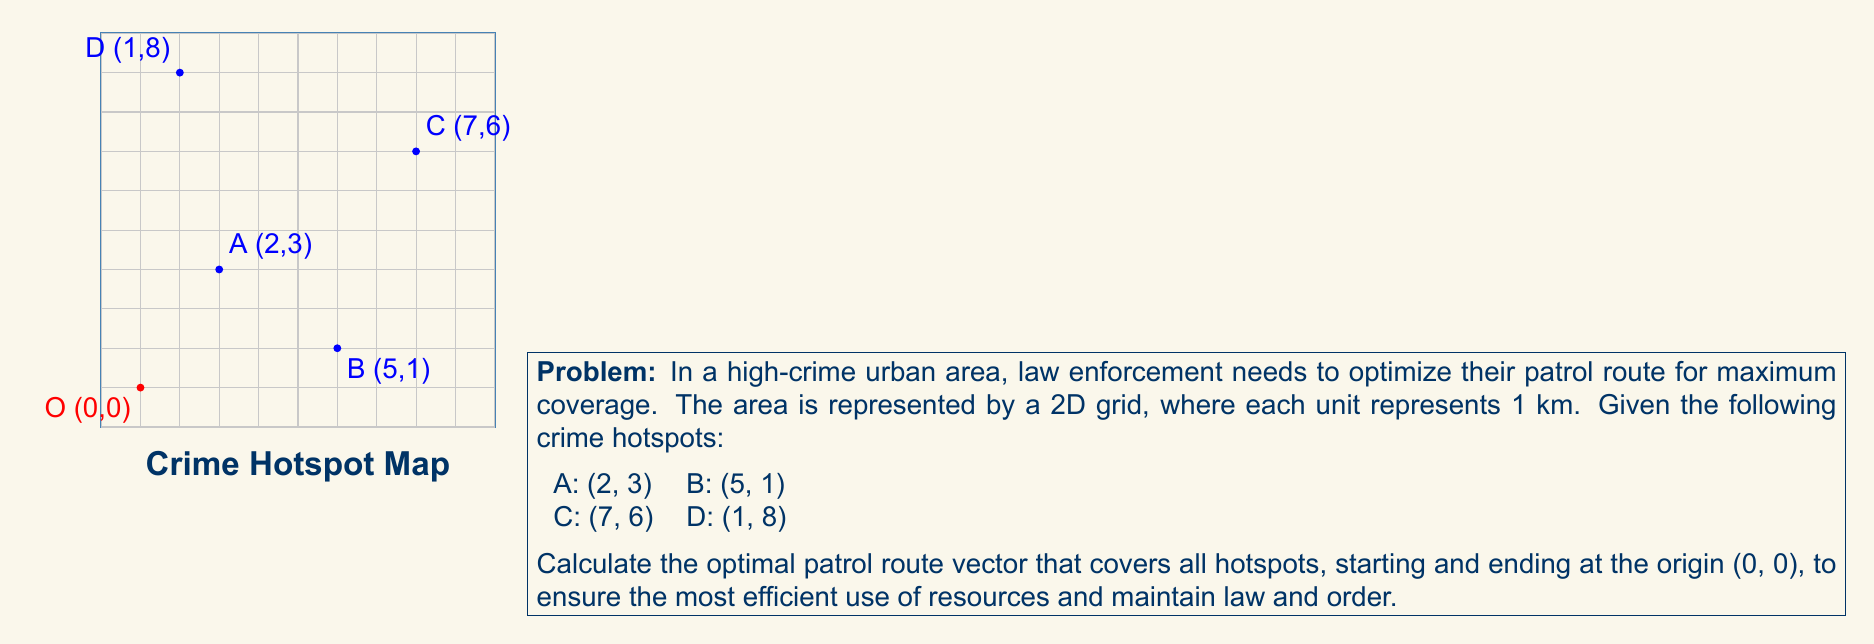Could you help me with this problem? To find the optimal patrol route vector, we need to calculate the displacement vectors between consecutive points in the most efficient order. Let's approach this step-by-step:

1) First, we need to determine the most efficient order to visit the hotspots. One possible efficient route is O → A → B → C → D → O.

2) Calculate displacement vectors:
   O to A: $\vec{OA} = (2-0, 3-0) = (2, 3)$
   A to B: $\vec{AB} = (5-2, 1-3) = (3, -2)$
   B to C: $\vec{BC} = (7-5, 6-1) = (2, 5)$
   C to D: $\vec{CD} = (1-7, 8-6) = (-6, 2)$
   D to O: $\vec{DO} = (0-1, 0-8) = (-1, -8)$

3) The optimal patrol route vector is the sum of these displacement vectors:
   $\vec{V} = \vec{OA} + \vec{AB} + \vec{BC} + \vec{CD} + \vec{DO}$

4) Substitute the values:
   $\vec{V} = (2, 3) + (3, -2) + (2, 5) + (-6, 2) + (-1, -8)$

5) Add the components:
   $\vec{V} = (2+3+2-6-1, 3-2+5+2-8)$
   $\vec{V} = (0, 0)$

The result $(0, 0)$ confirms that the route returns to the starting point.

6) To find the total distance traveled, we sum the magnitudes of each displacement vector:
   $|\vec{OA}| + |\vec{AB}| + |\vec{BC}| + |\vec{CD}| + |\vec{DO}|$
   $= \sqrt{2^2 + 3^2} + \sqrt{3^2 + (-2)^2} + \sqrt{2^2 + 5^2} + \sqrt{(-6)^2 + 2^2} + \sqrt{(-1)^2 + (-8)^2}$
   $\approx 3.61 + 3.61 + 5.39 + 6.32 + 8.06 = 26.99$ km

Therefore, the optimal patrol route covers approximately 27 km and efficiently visits all crime hotspots.
Answer: $\vec{V} = (0, 0)$, Total distance ≈ 27 km 